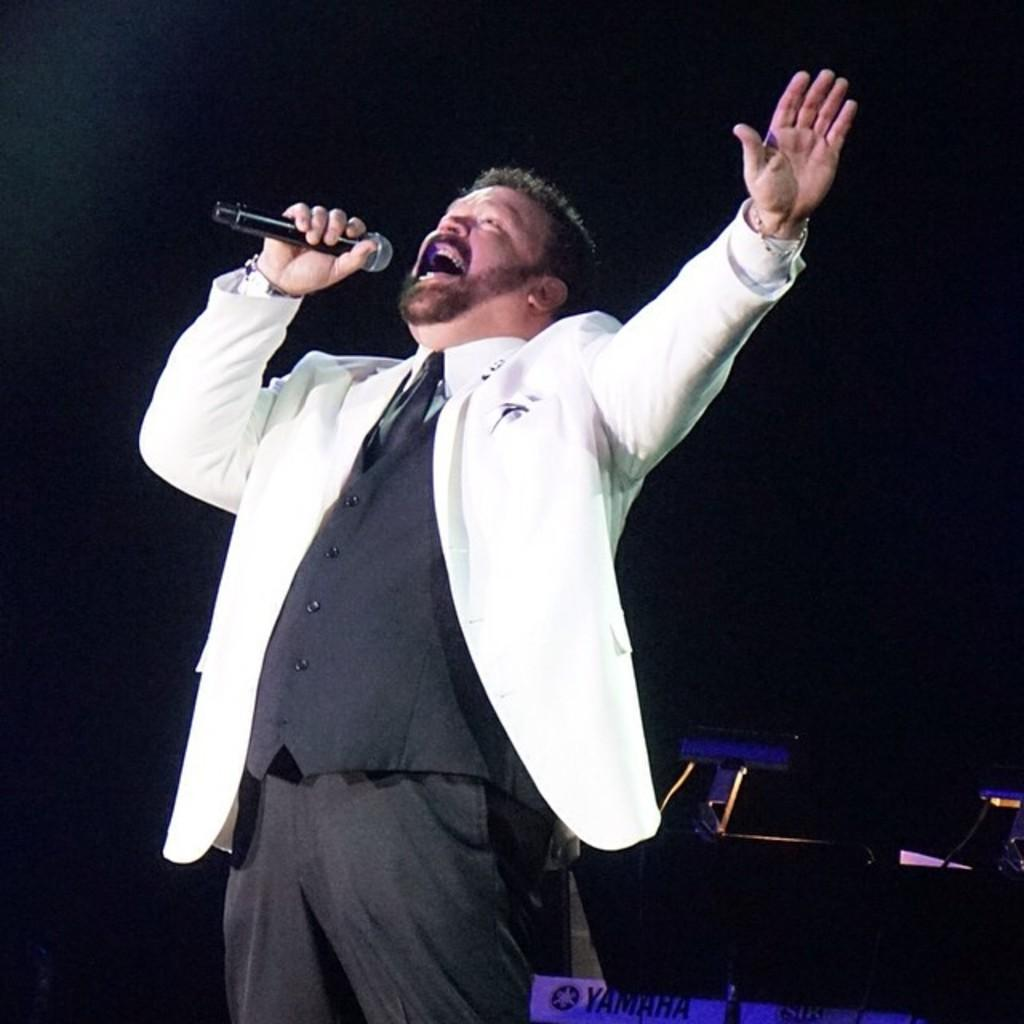Who is the main subject in the image? There is a man in the image. What is the man doing in the image? The man is standing and singing in the image. What object is the man holding in the image? The man is holding a microphone in the image. What is the man wearing in the image? The man is wearing a coat in the image. How many spiders are crawling on the man's coat in the image? There are no spiders visible in the image; the man is wearing a coat, but there are no spiders mentioned or depicted. 